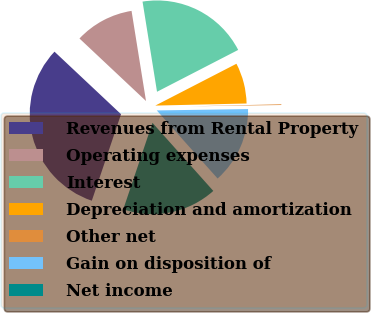Convert chart to OTSL. <chart><loc_0><loc_0><loc_500><loc_500><pie_chart><fcel>Revenues from Rental Property<fcel>Operating expenses<fcel>Interest<fcel>Depreciation and amortization<fcel>Other net<fcel>Gain on disposition of<fcel>Net income<nl><fcel>31.82%<fcel>10.46%<fcel>19.96%<fcel>7.21%<fcel>0.13%<fcel>13.63%<fcel>16.79%<nl></chart> 